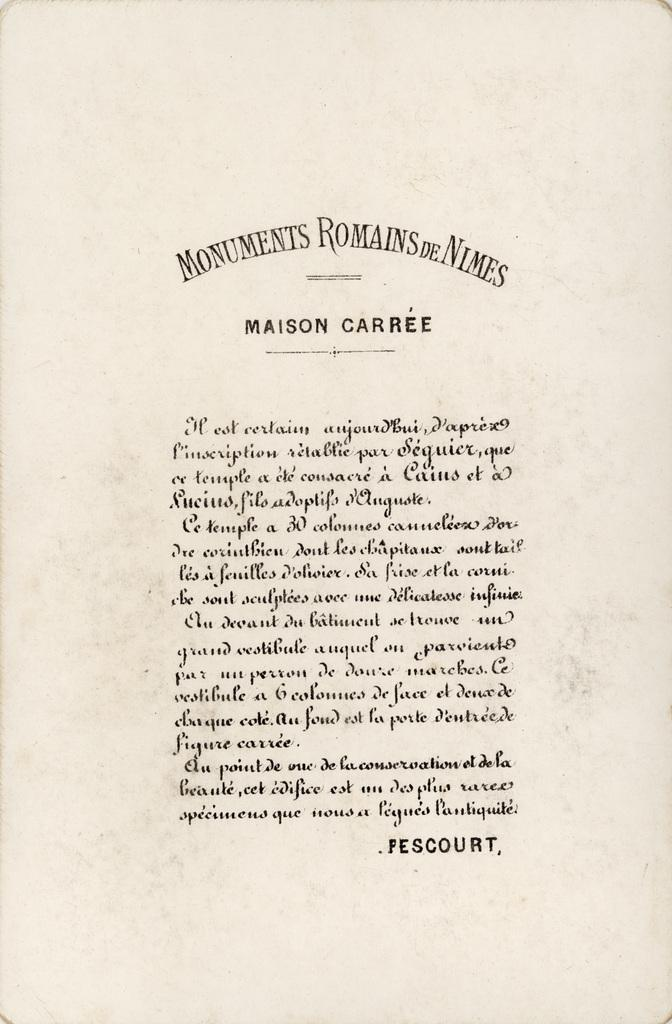<image>
Render a clear and concise summary of the photo. a old canvas paper with the title MONUMENTS ROMAINS DE NIMES at the top and MAISON CARREE after it, the rest unreadable in another language.. 